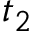Convert formula to latex. <formula><loc_0><loc_0><loc_500><loc_500>t _ { 2 }</formula> 